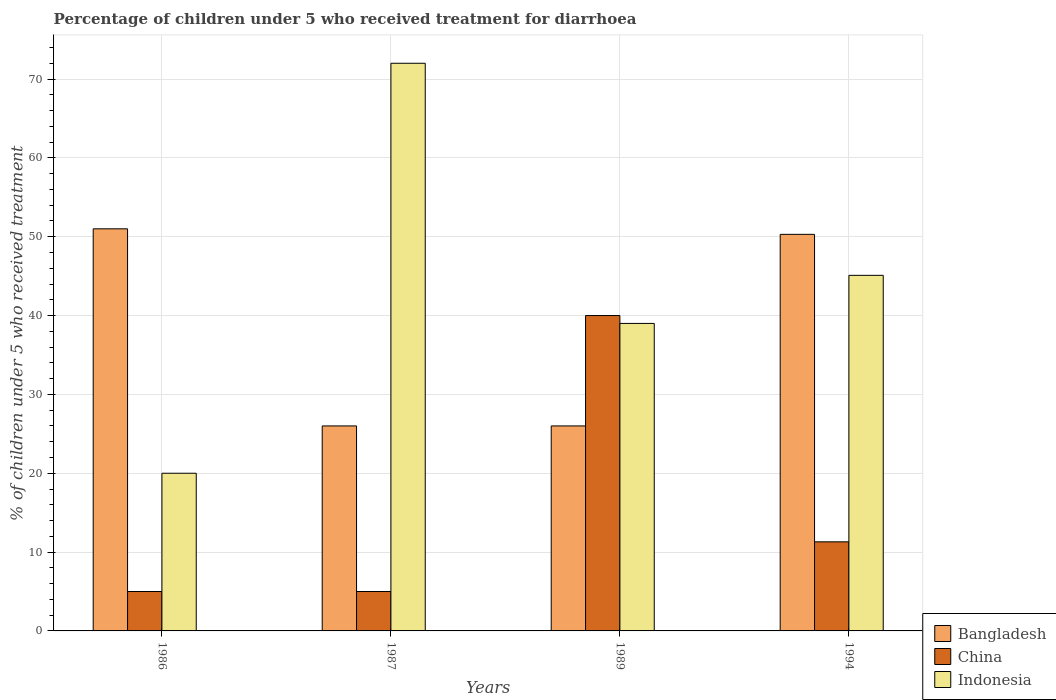How many groups of bars are there?
Give a very brief answer. 4. Are the number of bars on each tick of the X-axis equal?
Give a very brief answer. Yes. How many bars are there on the 3rd tick from the left?
Your answer should be compact. 3. What is the label of the 4th group of bars from the left?
Give a very brief answer. 1994. Across all years, what is the minimum percentage of children who received treatment for diarrhoea  in Indonesia?
Ensure brevity in your answer.  20. In which year was the percentage of children who received treatment for diarrhoea  in Indonesia minimum?
Make the answer very short. 1986. What is the total percentage of children who received treatment for diarrhoea  in Bangladesh in the graph?
Provide a short and direct response. 153.3. What is the difference between the percentage of children who received treatment for diarrhoea  in China in 1987 and that in 1994?
Provide a short and direct response. -6.3. What is the average percentage of children who received treatment for diarrhoea  in Indonesia per year?
Give a very brief answer. 44.02. In the year 1987, what is the difference between the percentage of children who received treatment for diarrhoea  in Bangladesh and percentage of children who received treatment for diarrhoea  in China?
Ensure brevity in your answer.  21. What is the ratio of the percentage of children who received treatment for diarrhoea  in China in 1987 to that in 1994?
Your answer should be compact. 0.44. Is the percentage of children who received treatment for diarrhoea  in China in 1986 less than that in 1994?
Your answer should be compact. Yes. Is the difference between the percentage of children who received treatment for diarrhoea  in Bangladesh in 1986 and 1994 greater than the difference between the percentage of children who received treatment for diarrhoea  in China in 1986 and 1994?
Offer a terse response. Yes. What is the difference between the highest and the second highest percentage of children who received treatment for diarrhoea  in Bangladesh?
Give a very brief answer. 0.7. In how many years, is the percentage of children who received treatment for diarrhoea  in Indonesia greater than the average percentage of children who received treatment for diarrhoea  in Indonesia taken over all years?
Ensure brevity in your answer.  2. What does the 2nd bar from the right in 1987 represents?
Make the answer very short. China. What is the difference between two consecutive major ticks on the Y-axis?
Offer a terse response. 10. Does the graph contain any zero values?
Offer a terse response. No. How are the legend labels stacked?
Keep it short and to the point. Vertical. What is the title of the graph?
Offer a very short reply. Percentage of children under 5 who received treatment for diarrhoea. What is the label or title of the Y-axis?
Provide a short and direct response. % of children under 5 who received treatment. What is the % of children under 5 who received treatment in Bangladesh in 1986?
Provide a short and direct response. 51. What is the % of children under 5 who received treatment of Bangladesh in 1987?
Keep it short and to the point. 26. What is the % of children under 5 who received treatment in Indonesia in 1987?
Offer a very short reply. 72. What is the % of children under 5 who received treatment in Indonesia in 1989?
Your answer should be compact. 39. What is the % of children under 5 who received treatment of Bangladesh in 1994?
Offer a terse response. 50.3. What is the % of children under 5 who received treatment in China in 1994?
Give a very brief answer. 11.3. What is the % of children under 5 who received treatment in Indonesia in 1994?
Provide a short and direct response. 45.1. Across all years, what is the maximum % of children under 5 who received treatment of Bangladesh?
Your answer should be very brief. 51. Across all years, what is the maximum % of children under 5 who received treatment in China?
Provide a short and direct response. 40. Across all years, what is the maximum % of children under 5 who received treatment of Indonesia?
Provide a short and direct response. 72. What is the total % of children under 5 who received treatment of Bangladesh in the graph?
Give a very brief answer. 153.3. What is the total % of children under 5 who received treatment in China in the graph?
Offer a very short reply. 61.3. What is the total % of children under 5 who received treatment in Indonesia in the graph?
Provide a short and direct response. 176.1. What is the difference between the % of children under 5 who received treatment of Bangladesh in 1986 and that in 1987?
Keep it short and to the point. 25. What is the difference between the % of children under 5 who received treatment of Indonesia in 1986 and that in 1987?
Ensure brevity in your answer.  -52. What is the difference between the % of children under 5 who received treatment of Bangladesh in 1986 and that in 1989?
Offer a terse response. 25. What is the difference between the % of children under 5 who received treatment of China in 1986 and that in 1989?
Provide a succinct answer. -35. What is the difference between the % of children under 5 who received treatment of Bangladesh in 1986 and that in 1994?
Keep it short and to the point. 0.7. What is the difference between the % of children under 5 who received treatment of China in 1986 and that in 1994?
Keep it short and to the point. -6.3. What is the difference between the % of children under 5 who received treatment in Indonesia in 1986 and that in 1994?
Your answer should be very brief. -25.1. What is the difference between the % of children under 5 who received treatment in Bangladesh in 1987 and that in 1989?
Keep it short and to the point. 0. What is the difference between the % of children under 5 who received treatment in China in 1987 and that in 1989?
Make the answer very short. -35. What is the difference between the % of children under 5 who received treatment in Bangladesh in 1987 and that in 1994?
Offer a terse response. -24.3. What is the difference between the % of children under 5 who received treatment in Indonesia in 1987 and that in 1994?
Give a very brief answer. 26.9. What is the difference between the % of children under 5 who received treatment of Bangladesh in 1989 and that in 1994?
Provide a short and direct response. -24.3. What is the difference between the % of children under 5 who received treatment in China in 1989 and that in 1994?
Your answer should be compact. 28.7. What is the difference between the % of children under 5 who received treatment of Indonesia in 1989 and that in 1994?
Offer a very short reply. -6.1. What is the difference between the % of children under 5 who received treatment of China in 1986 and the % of children under 5 who received treatment of Indonesia in 1987?
Your answer should be compact. -67. What is the difference between the % of children under 5 who received treatment in Bangladesh in 1986 and the % of children under 5 who received treatment in China in 1989?
Provide a short and direct response. 11. What is the difference between the % of children under 5 who received treatment in Bangladesh in 1986 and the % of children under 5 who received treatment in Indonesia in 1989?
Offer a terse response. 12. What is the difference between the % of children under 5 who received treatment in China in 1986 and the % of children under 5 who received treatment in Indonesia in 1989?
Provide a short and direct response. -34. What is the difference between the % of children under 5 who received treatment in Bangladesh in 1986 and the % of children under 5 who received treatment in China in 1994?
Offer a very short reply. 39.7. What is the difference between the % of children under 5 who received treatment in China in 1986 and the % of children under 5 who received treatment in Indonesia in 1994?
Ensure brevity in your answer.  -40.1. What is the difference between the % of children under 5 who received treatment of Bangladesh in 1987 and the % of children under 5 who received treatment of Indonesia in 1989?
Keep it short and to the point. -13. What is the difference between the % of children under 5 who received treatment in China in 1987 and the % of children under 5 who received treatment in Indonesia in 1989?
Provide a succinct answer. -34. What is the difference between the % of children under 5 who received treatment in Bangladesh in 1987 and the % of children under 5 who received treatment in Indonesia in 1994?
Your answer should be compact. -19.1. What is the difference between the % of children under 5 who received treatment of China in 1987 and the % of children under 5 who received treatment of Indonesia in 1994?
Your response must be concise. -40.1. What is the difference between the % of children under 5 who received treatment of Bangladesh in 1989 and the % of children under 5 who received treatment of Indonesia in 1994?
Offer a very short reply. -19.1. What is the difference between the % of children under 5 who received treatment of China in 1989 and the % of children under 5 who received treatment of Indonesia in 1994?
Offer a very short reply. -5.1. What is the average % of children under 5 who received treatment in Bangladesh per year?
Offer a terse response. 38.33. What is the average % of children under 5 who received treatment of China per year?
Offer a very short reply. 15.32. What is the average % of children under 5 who received treatment in Indonesia per year?
Your answer should be very brief. 44.02. In the year 1986, what is the difference between the % of children under 5 who received treatment of Bangladesh and % of children under 5 who received treatment of China?
Your answer should be very brief. 46. In the year 1987, what is the difference between the % of children under 5 who received treatment in Bangladesh and % of children under 5 who received treatment in Indonesia?
Provide a short and direct response. -46. In the year 1987, what is the difference between the % of children under 5 who received treatment of China and % of children under 5 who received treatment of Indonesia?
Your answer should be compact. -67. In the year 1989, what is the difference between the % of children under 5 who received treatment of China and % of children under 5 who received treatment of Indonesia?
Keep it short and to the point. 1. In the year 1994, what is the difference between the % of children under 5 who received treatment of China and % of children under 5 who received treatment of Indonesia?
Your answer should be compact. -33.8. What is the ratio of the % of children under 5 who received treatment of Bangladesh in 1986 to that in 1987?
Keep it short and to the point. 1.96. What is the ratio of the % of children under 5 who received treatment of Indonesia in 1986 to that in 1987?
Your answer should be very brief. 0.28. What is the ratio of the % of children under 5 who received treatment in Bangladesh in 1986 to that in 1989?
Your response must be concise. 1.96. What is the ratio of the % of children under 5 who received treatment in China in 1986 to that in 1989?
Offer a terse response. 0.12. What is the ratio of the % of children under 5 who received treatment of Indonesia in 1986 to that in 1989?
Offer a very short reply. 0.51. What is the ratio of the % of children under 5 who received treatment in Bangladesh in 1986 to that in 1994?
Provide a succinct answer. 1.01. What is the ratio of the % of children under 5 who received treatment in China in 1986 to that in 1994?
Ensure brevity in your answer.  0.44. What is the ratio of the % of children under 5 who received treatment of Indonesia in 1986 to that in 1994?
Your answer should be very brief. 0.44. What is the ratio of the % of children under 5 who received treatment of Indonesia in 1987 to that in 1989?
Ensure brevity in your answer.  1.85. What is the ratio of the % of children under 5 who received treatment in Bangladesh in 1987 to that in 1994?
Provide a short and direct response. 0.52. What is the ratio of the % of children under 5 who received treatment of China in 1987 to that in 1994?
Keep it short and to the point. 0.44. What is the ratio of the % of children under 5 who received treatment of Indonesia in 1987 to that in 1994?
Your answer should be compact. 1.6. What is the ratio of the % of children under 5 who received treatment in Bangladesh in 1989 to that in 1994?
Provide a succinct answer. 0.52. What is the ratio of the % of children under 5 who received treatment in China in 1989 to that in 1994?
Ensure brevity in your answer.  3.54. What is the ratio of the % of children under 5 who received treatment of Indonesia in 1989 to that in 1994?
Ensure brevity in your answer.  0.86. What is the difference between the highest and the second highest % of children under 5 who received treatment in China?
Make the answer very short. 28.7. What is the difference between the highest and the second highest % of children under 5 who received treatment of Indonesia?
Offer a terse response. 26.9. What is the difference between the highest and the lowest % of children under 5 who received treatment of Bangladesh?
Offer a terse response. 25. What is the difference between the highest and the lowest % of children under 5 who received treatment in Indonesia?
Your answer should be compact. 52. 